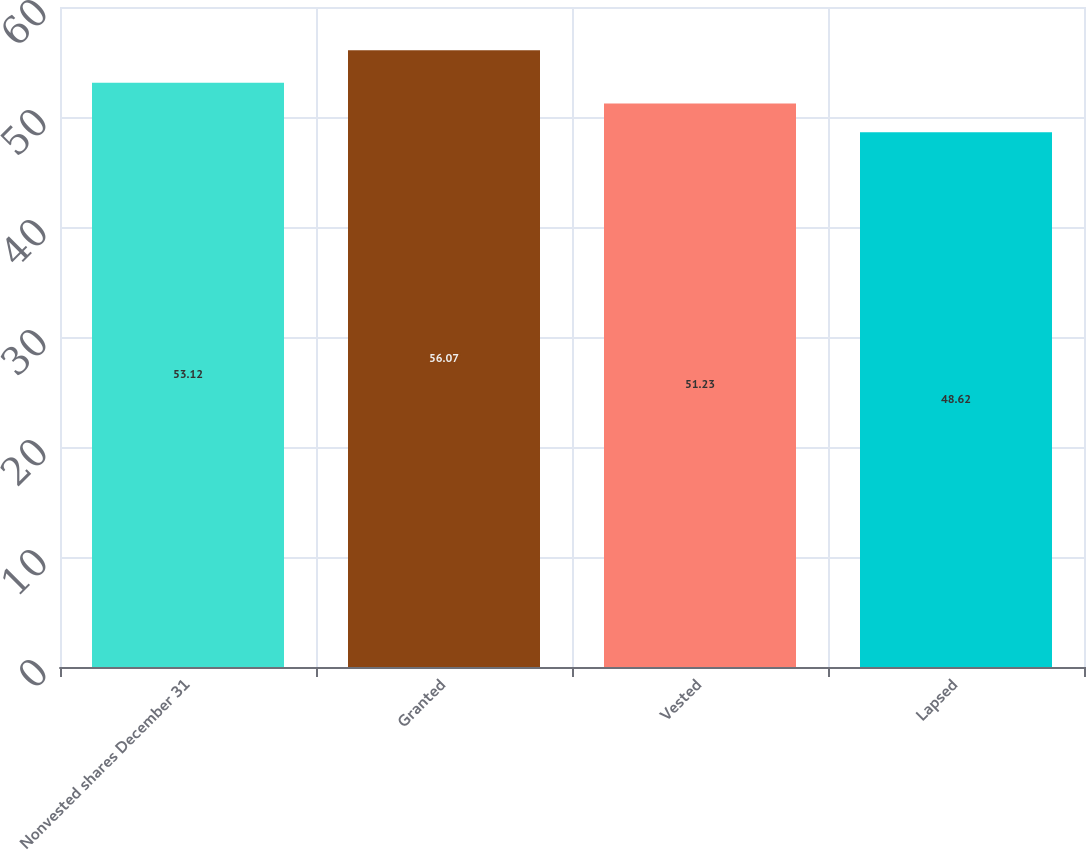Convert chart to OTSL. <chart><loc_0><loc_0><loc_500><loc_500><bar_chart><fcel>Nonvested shares December 31<fcel>Granted<fcel>Vested<fcel>Lapsed<nl><fcel>53.12<fcel>56.07<fcel>51.23<fcel>48.62<nl></chart> 